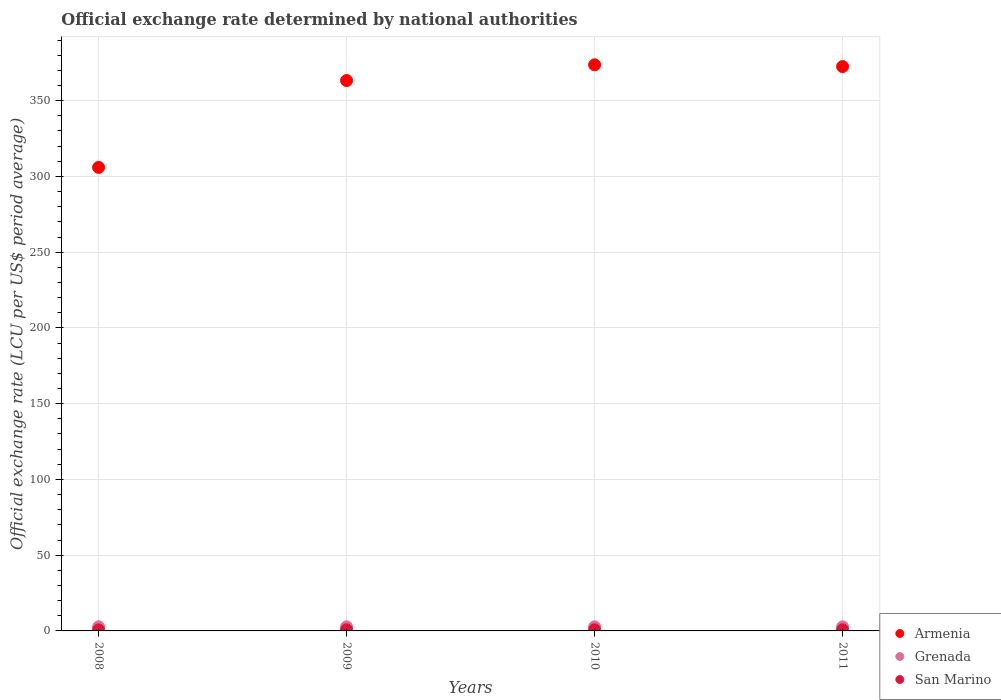How many different coloured dotlines are there?
Your response must be concise. 3. What is the official exchange rate in San Marino in 2010?
Provide a succinct answer. 0.76. Across all years, what is the maximum official exchange rate in Armenia?
Make the answer very short. 373.66. Across all years, what is the minimum official exchange rate in Armenia?
Your response must be concise. 305.97. In which year was the official exchange rate in Grenada maximum?
Ensure brevity in your answer.  2008. In which year was the official exchange rate in San Marino minimum?
Offer a very short reply. 2008. What is the total official exchange rate in Armenia in the graph?
Your response must be concise. 1415.41. What is the difference between the official exchange rate in Armenia in 2009 and the official exchange rate in San Marino in 2008?
Offer a very short reply. 362.6. What is the average official exchange rate in San Marino per year?
Provide a short and direct response. 0.72. In the year 2008, what is the difference between the official exchange rate in San Marino and official exchange rate in Grenada?
Keep it short and to the point. -2.02. In how many years, is the official exchange rate in San Marino greater than 160 LCU?
Make the answer very short. 0. What is the ratio of the official exchange rate in Armenia in 2009 to that in 2010?
Your answer should be very brief. 0.97. What is the difference between the highest and the second highest official exchange rate in San Marino?
Make the answer very short. 0.04. What is the difference between the highest and the lowest official exchange rate in Armenia?
Provide a succinct answer. 67.69. In how many years, is the official exchange rate in Grenada greater than the average official exchange rate in Grenada taken over all years?
Offer a terse response. 0. Is it the case that in every year, the sum of the official exchange rate in San Marino and official exchange rate in Armenia  is greater than the official exchange rate in Grenada?
Your response must be concise. Yes. Is the official exchange rate in San Marino strictly greater than the official exchange rate in Grenada over the years?
Your response must be concise. No. Is the official exchange rate in San Marino strictly less than the official exchange rate in Grenada over the years?
Your answer should be compact. Yes. How many dotlines are there?
Keep it short and to the point. 3. How many years are there in the graph?
Keep it short and to the point. 4. What is the difference between two consecutive major ticks on the Y-axis?
Provide a short and direct response. 50. Are the values on the major ticks of Y-axis written in scientific E-notation?
Make the answer very short. No. Does the graph contain grids?
Make the answer very short. Yes. Where does the legend appear in the graph?
Your answer should be very brief. Bottom right. How are the legend labels stacked?
Give a very brief answer. Vertical. What is the title of the graph?
Offer a very short reply. Official exchange rate determined by national authorities. Does "Bulgaria" appear as one of the legend labels in the graph?
Make the answer very short. No. What is the label or title of the X-axis?
Your answer should be compact. Years. What is the label or title of the Y-axis?
Ensure brevity in your answer.  Official exchange rate (LCU per US$ period average). What is the Official exchange rate (LCU per US$ period average) of Armenia in 2008?
Your answer should be very brief. 305.97. What is the Official exchange rate (LCU per US$ period average) in San Marino in 2008?
Your response must be concise. 0.68. What is the Official exchange rate (LCU per US$ period average) in Armenia in 2009?
Give a very brief answer. 363.28. What is the Official exchange rate (LCU per US$ period average) in San Marino in 2009?
Ensure brevity in your answer.  0.72. What is the Official exchange rate (LCU per US$ period average) in Armenia in 2010?
Your answer should be very brief. 373.66. What is the Official exchange rate (LCU per US$ period average) of San Marino in 2010?
Ensure brevity in your answer.  0.76. What is the Official exchange rate (LCU per US$ period average) of Armenia in 2011?
Offer a terse response. 372.5. What is the Official exchange rate (LCU per US$ period average) of San Marino in 2011?
Your response must be concise. 0.72. Across all years, what is the maximum Official exchange rate (LCU per US$ period average) of Armenia?
Make the answer very short. 373.66. Across all years, what is the maximum Official exchange rate (LCU per US$ period average) of Grenada?
Your answer should be very brief. 2.7. Across all years, what is the maximum Official exchange rate (LCU per US$ period average) in San Marino?
Offer a terse response. 0.76. Across all years, what is the minimum Official exchange rate (LCU per US$ period average) of Armenia?
Provide a succinct answer. 305.97. Across all years, what is the minimum Official exchange rate (LCU per US$ period average) of Grenada?
Your answer should be very brief. 2.7. Across all years, what is the minimum Official exchange rate (LCU per US$ period average) of San Marino?
Provide a succinct answer. 0.68. What is the total Official exchange rate (LCU per US$ period average) of Armenia in the graph?
Give a very brief answer. 1415.41. What is the total Official exchange rate (LCU per US$ period average) in Grenada in the graph?
Make the answer very short. 10.8. What is the total Official exchange rate (LCU per US$ period average) of San Marino in the graph?
Give a very brief answer. 2.88. What is the difference between the Official exchange rate (LCU per US$ period average) of Armenia in 2008 and that in 2009?
Provide a short and direct response. -57.31. What is the difference between the Official exchange rate (LCU per US$ period average) of San Marino in 2008 and that in 2009?
Offer a terse response. -0.04. What is the difference between the Official exchange rate (LCU per US$ period average) of Armenia in 2008 and that in 2010?
Provide a short and direct response. -67.69. What is the difference between the Official exchange rate (LCU per US$ period average) of San Marino in 2008 and that in 2010?
Ensure brevity in your answer.  -0.07. What is the difference between the Official exchange rate (LCU per US$ period average) of Armenia in 2008 and that in 2011?
Your response must be concise. -66.53. What is the difference between the Official exchange rate (LCU per US$ period average) of San Marino in 2008 and that in 2011?
Keep it short and to the point. -0.04. What is the difference between the Official exchange rate (LCU per US$ period average) of Armenia in 2009 and that in 2010?
Keep it short and to the point. -10.38. What is the difference between the Official exchange rate (LCU per US$ period average) of San Marino in 2009 and that in 2010?
Make the answer very short. -0.04. What is the difference between the Official exchange rate (LCU per US$ period average) of Armenia in 2009 and that in 2011?
Give a very brief answer. -9.22. What is the difference between the Official exchange rate (LCU per US$ period average) in Grenada in 2009 and that in 2011?
Give a very brief answer. 0. What is the difference between the Official exchange rate (LCU per US$ period average) of Armenia in 2010 and that in 2011?
Provide a succinct answer. 1.16. What is the difference between the Official exchange rate (LCU per US$ period average) in Grenada in 2010 and that in 2011?
Offer a terse response. 0. What is the difference between the Official exchange rate (LCU per US$ period average) of San Marino in 2010 and that in 2011?
Give a very brief answer. 0.04. What is the difference between the Official exchange rate (LCU per US$ period average) of Armenia in 2008 and the Official exchange rate (LCU per US$ period average) of Grenada in 2009?
Give a very brief answer. 303.27. What is the difference between the Official exchange rate (LCU per US$ period average) of Armenia in 2008 and the Official exchange rate (LCU per US$ period average) of San Marino in 2009?
Make the answer very short. 305.25. What is the difference between the Official exchange rate (LCU per US$ period average) of Grenada in 2008 and the Official exchange rate (LCU per US$ period average) of San Marino in 2009?
Provide a short and direct response. 1.98. What is the difference between the Official exchange rate (LCU per US$ period average) in Armenia in 2008 and the Official exchange rate (LCU per US$ period average) in Grenada in 2010?
Your response must be concise. 303.27. What is the difference between the Official exchange rate (LCU per US$ period average) of Armenia in 2008 and the Official exchange rate (LCU per US$ period average) of San Marino in 2010?
Your answer should be very brief. 305.21. What is the difference between the Official exchange rate (LCU per US$ period average) in Grenada in 2008 and the Official exchange rate (LCU per US$ period average) in San Marino in 2010?
Offer a very short reply. 1.95. What is the difference between the Official exchange rate (LCU per US$ period average) in Armenia in 2008 and the Official exchange rate (LCU per US$ period average) in Grenada in 2011?
Provide a short and direct response. 303.27. What is the difference between the Official exchange rate (LCU per US$ period average) in Armenia in 2008 and the Official exchange rate (LCU per US$ period average) in San Marino in 2011?
Ensure brevity in your answer.  305.25. What is the difference between the Official exchange rate (LCU per US$ period average) of Grenada in 2008 and the Official exchange rate (LCU per US$ period average) of San Marino in 2011?
Make the answer very short. 1.98. What is the difference between the Official exchange rate (LCU per US$ period average) of Armenia in 2009 and the Official exchange rate (LCU per US$ period average) of Grenada in 2010?
Give a very brief answer. 360.58. What is the difference between the Official exchange rate (LCU per US$ period average) of Armenia in 2009 and the Official exchange rate (LCU per US$ period average) of San Marino in 2010?
Keep it short and to the point. 362.53. What is the difference between the Official exchange rate (LCU per US$ period average) in Grenada in 2009 and the Official exchange rate (LCU per US$ period average) in San Marino in 2010?
Offer a very short reply. 1.95. What is the difference between the Official exchange rate (LCU per US$ period average) of Armenia in 2009 and the Official exchange rate (LCU per US$ period average) of Grenada in 2011?
Ensure brevity in your answer.  360.58. What is the difference between the Official exchange rate (LCU per US$ period average) in Armenia in 2009 and the Official exchange rate (LCU per US$ period average) in San Marino in 2011?
Provide a short and direct response. 362.56. What is the difference between the Official exchange rate (LCU per US$ period average) of Grenada in 2009 and the Official exchange rate (LCU per US$ period average) of San Marino in 2011?
Provide a short and direct response. 1.98. What is the difference between the Official exchange rate (LCU per US$ period average) of Armenia in 2010 and the Official exchange rate (LCU per US$ period average) of Grenada in 2011?
Give a very brief answer. 370.96. What is the difference between the Official exchange rate (LCU per US$ period average) in Armenia in 2010 and the Official exchange rate (LCU per US$ period average) in San Marino in 2011?
Offer a very short reply. 372.94. What is the difference between the Official exchange rate (LCU per US$ period average) of Grenada in 2010 and the Official exchange rate (LCU per US$ period average) of San Marino in 2011?
Your answer should be compact. 1.98. What is the average Official exchange rate (LCU per US$ period average) of Armenia per year?
Your response must be concise. 353.85. What is the average Official exchange rate (LCU per US$ period average) in San Marino per year?
Ensure brevity in your answer.  0.72. In the year 2008, what is the difference between the Official exchange rate (LCU per US$ period average) of Armenia and Official exchange rate (LCU per US$ period average) of Grenada?
Ensure brevity in your answer.  303.27. In the year 2008, what is the difference between the Official exchange rate (LCU per US$ period average) of Armenia and Official exchange rate (LCU per US$ period average) of San Marino?
Keep it short and to the point. 305.29. In the year 2008, what is the difference between the Official exchange rate (LCU per US$ period average) in Grenada and Official exchange rate (LCU per US$ period average) in San Marino?
Offer a very short reply. 2.02. In the year 2009, what is the difference between the Official exchange rate (LCU per US$ period average) of Armenia and Official exchange rate (LCU per US$ period average) of Grenada?
Keep it short and to the point. 360.58. In the year 2009, what is the difference between the Official exchange rate (LCU per US$ period average) of Armenia and Official exchange rate (LCU per US$ period average) of San Marino?
Provide a short and direct response. 362.56. In the year 2009, what is the difference between the Official exchange rate (LCU per US$ period average) of Grenada and Official exchange rate (LCU per US$ period average) of San Marino?
Ensure brevity in your answer.  1.98. In the year 2010, what is the difference between the Official exchange rate (LCU per US$ period average) in Armenia and Official exchange rate (LCU per US$ period average) in Grenada?
Provide a succinct answer. 370.96. In the year 2010, what is the difference between the Official exchange rate (LCU per US$ period average) of Armenia and Official exchange rate (LCU per US$ period average) of San Marino?
Your answer should be very brief. 372.91. In the year 2010, what is the difference between the Official exchange rate (LCU per US$ period average) of Grenada and Official exchange rate (LCU per US$ period average) of San Marino?
Your answer should be compact. 1.95. In the year 2011, what is the difference between the Official exchange rate (LCU per US$ period average) in Armenia and Official exchange rate (LCU per US$ period average) in Grenada?
Make the answer very short. 369.8. In the year 2011, what is the difference between the Official exchange rate (LCU per US$ period average) of Armenia and Official exchange rate (LCU per US$ period average) of San Marino?
Provide a short and direct response. 371.78. In the year 2011, what is the difference between the Official exchange rate (LCU per US$ period average) of Grenada and Official exchange rate (LCU per US$ period average) of San Marino?
Provide a succinct answer. 1.98. What is the ratio of the Official exchange rate (LCU per US$ period average) in Armenia in 2008 to that in 2009?
Your response must be concise. 0.84. What is the ratio of the Official exchange rate (LCU per US$ period average) of San Marino in 2008 to that in 2009?
Ensure brevity in your answer.  0.95. What is the ratio of the Official exchange rate (LCU per US$ period average) of Armenia in 2008 to that in 2010?
Offer a very short reply. 0.82. What is the ratio of the Official exchange rate (LCU per US$ period average) of San Marino in 2008 to that in 2010?
Offer a very short reply. 0.9. What is the ratio of the Official exchange rate (LCU per US$ period average) in Armenia in 2008 to that in 2011?
Make the answer very short. 0.82. What is the ratio of the Official exchange rate (LCU per US$ period average) of San Marino in 2008 to that in 2011?
Your answer should be compact. 0.95. What is the ratio of the Official exchange rate (LCU per US$ period average) of Armenia in 2009 to that in 2010?
Offer a very short reply. 0.97. What is the ratio of the Official exchange rate (LCU per US$ period average) of San Marino in 2009 to that in 2010?
Provide a succinct answer. 0.95. What is the ratio of the Official exchange rate (LCU per US$ period average) of Armenia in 2009 to that in 2011?
Offer a terse response. 0.98. What is the ratio of the Official exchange rate (LCU per US$ period average) of Grenada in 2009 to that in 2011?
Give a very brief answer. 1. What is the ratio of the Official exchange rate (LCU per US$ period average) in San Marino in 2009 to that in 2011?
Give a very brief answer. 1. What is the ratio of the Official exchange rate (LCU per US$ period average) of Grenada in 2010 to that in 2011?
Keep it short and to the point. 1. What is the ratio of the Official exchange rate (LCU per US$ period average) of San Marino in 2010 to that in 2011?
Your answer should be compact. 1.05. What is the difference between the highest and the second highest Official exchange rate (LCU per US$ period average) of Armenia?
Ensure brevity in your answer.  1.16. What is the difference between the highest and the second highest Official exchange rate (LCU per US$ period average) in San Marino?
Offer a very short reply. 0.04. What is the difference between the highest and the lowest Official exchange rate (LCU per US$ period average) of Armenia?
Your answer should be very brief. 67.69. What is the difference between the highest and the lowest Official exchange rate (LCU per US$ period average) of Grenada?
Give a very brief answer. 0. What is the difference between the highest and the lowest Official exchange rate (LCU per US$ period average) of San Marino?
Offer a very short reply. 0.07. 